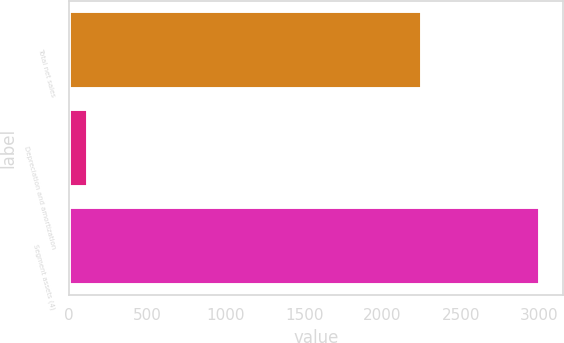Convert chart. <chart><loc_0><loc_0><loc_500><loc_500><bar_chart><fcel>Total net sales<fcel>Depreciation and amortization<fcel>Segment assets (4)<nl><fcel>2249<fcel>121<fcel>3003<nl></chart> 